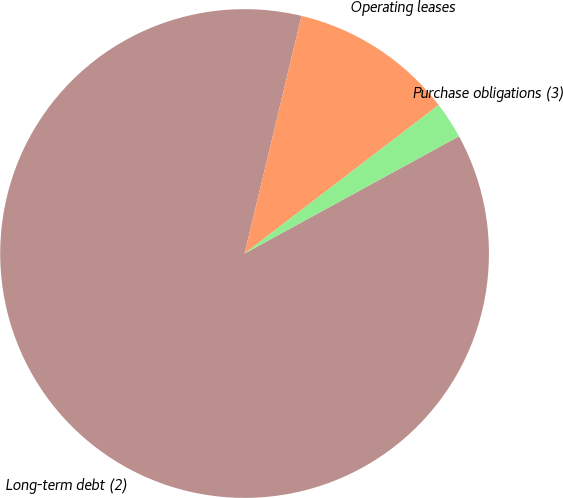Convert chart to OTSL. <chart><loc_0><loc_0><loc_500><loc_500><pie_chart><fcel>Long-term debt (2)<fcel>Operating leases<fcel>Purchase obligations (3)<nl><fcel>86.71%<fcel>10.86%<fcel>2.43%<nl></chart> 